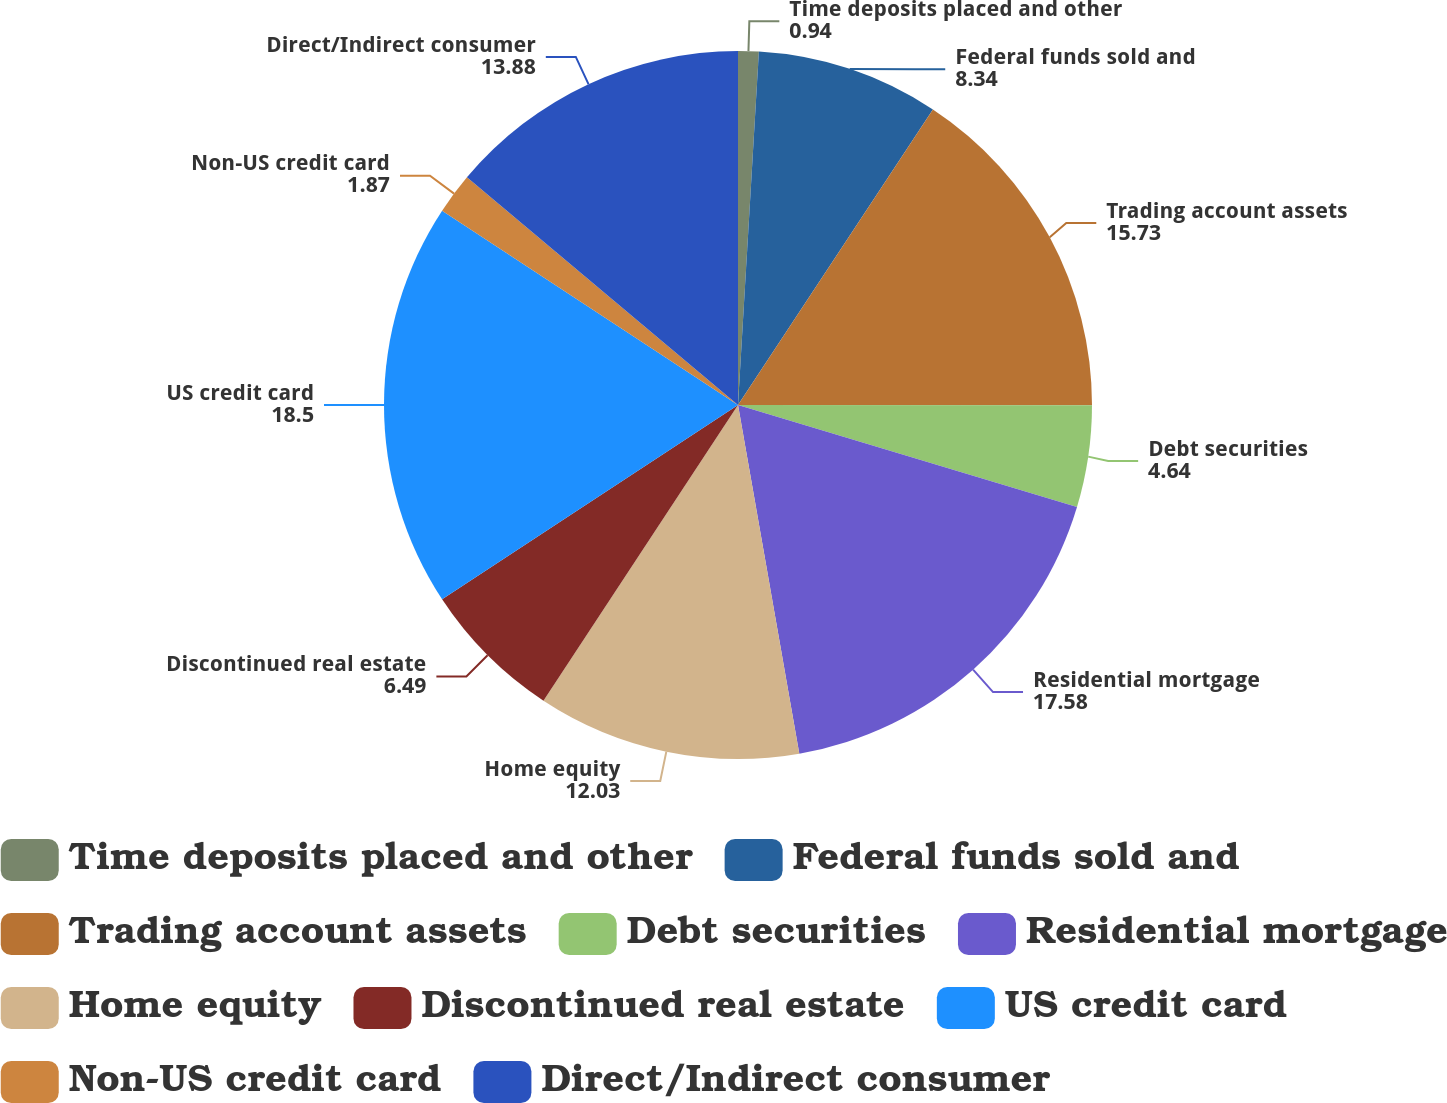Convert chart to OTSL. <chart><loc_0><loc_0><loc_500><loc_500><pie_chart><fcel>Time deposits placed and other<fcel>Federal funds sold and<fcel>Trading account assets<fcel>Debt securities<fcel>Residential mortgage<fcel>Home equity<fcel>Discontinued real estate<fcel>US credit card<fcel>Non-US credit card<fcel>Direct/Indirect consumer<nl><fcel>0.94%<fcel>8.34%<fcel>15.73%<fcel>4.64%<fcel>17.58%<fcel>12.03%<fcel>6.49%<fcel>18.5%<fcel>1.87%<fcel>13.88%<nl></chart> 